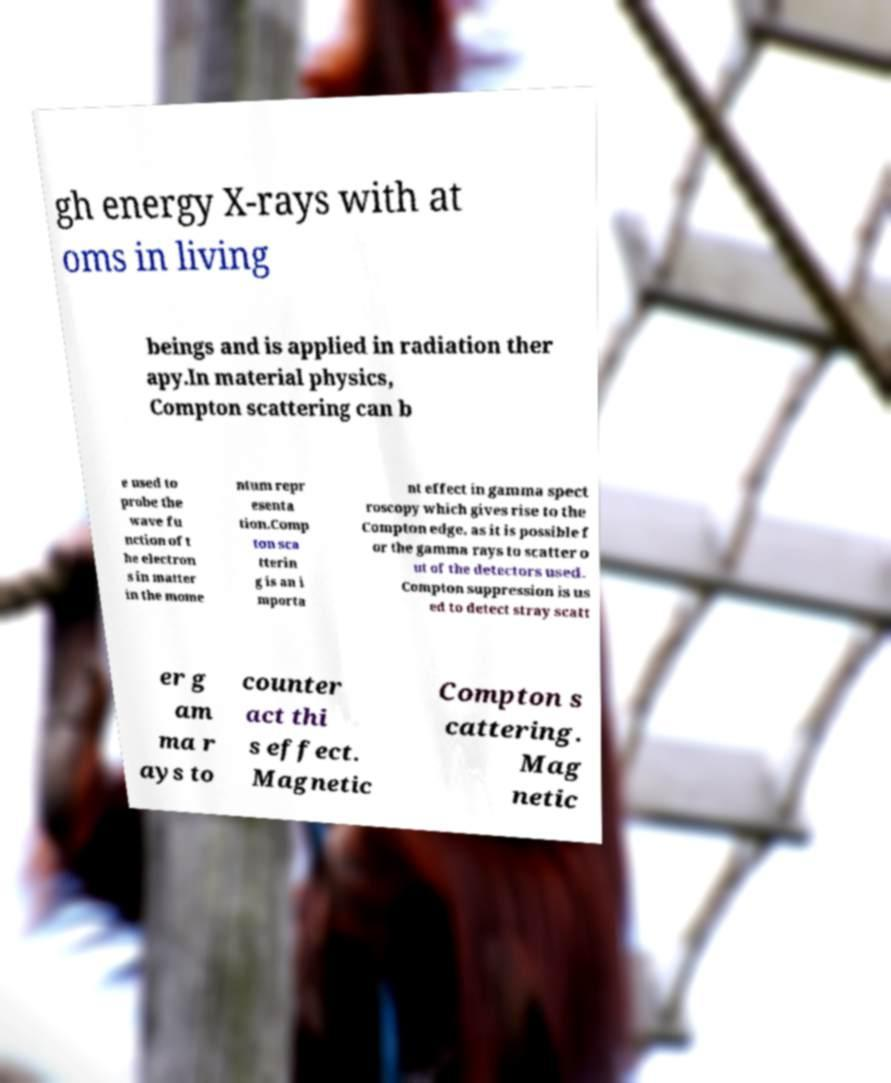Please read and relay the text visible in this image. What does it say? gh energy X-rays with at oms in living beings and is applied in radiation ther apy.In material physics, Compton scattering can b e used to probe the wave fu nction of t he electron s in matter in the mome ntum repr esenta tion.Comp ton sca tterin g is an i mporta nt effect in gamma spect roscopy which gives rise to the Compton edge, as it is possible f or the gamma rays to scatter o ut of the detectors used. Compton suppression is us ed to detect stray scatt er g am ma r ays to counter act thi s effect. Magnetic Compton s cattering. Mag netic 